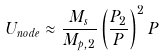<formula> <loc_0><loc_0><loc_500><loc_500>U _ { n o d e } \approx \frac { M _ { s } } { M _ { p , 2 } } \left ( \frac { P _ { 2 } } { P } \right ) ^ { 2 } P</formula> 